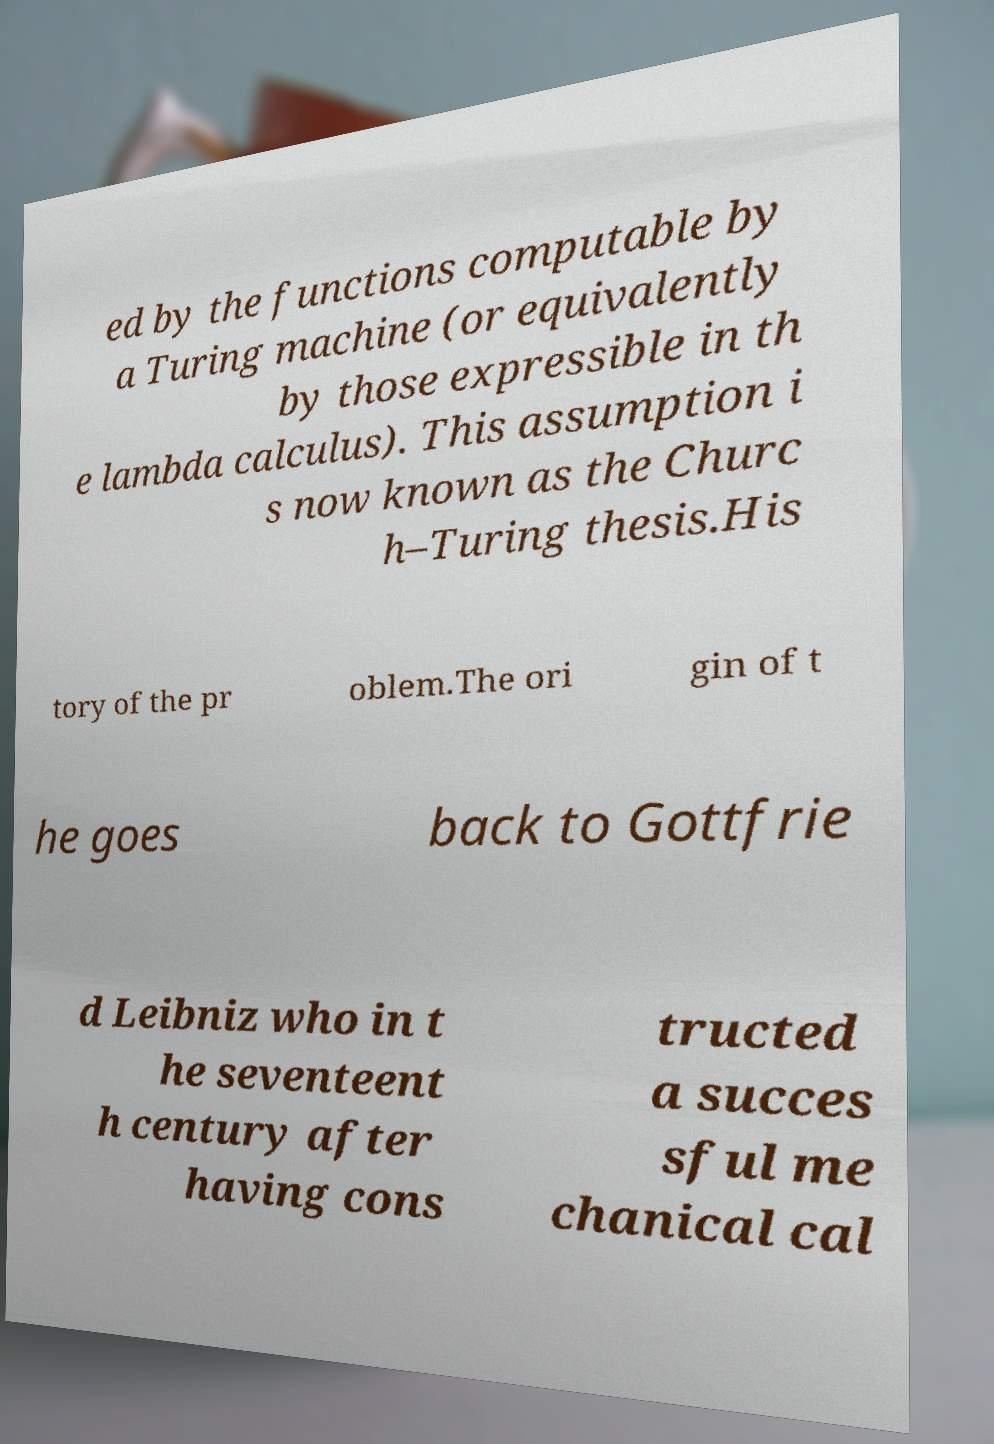There's text embedded in this image that I need extracted. Can you transcribe it verbatim? ed by the functions computable by a Turing machine (or equivalently by those expressible in th e lambda calculus). This assumption i s now known as the Churc h–Turing thesis.His tory of the pr oblem.The ori gin of t he goes back to Gottfrie d Leibniz who in t he seventeent h century after having cons tructed a succes sful me chanical cal 